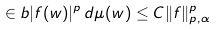<formula> <loc_0><loc_0><loc_500><loc_500>\in b | f ( w ) | ^ { p } \, d \mu ( w ) \leq C \| f \| ^ { p } _ { p , \alpha }</formula> 